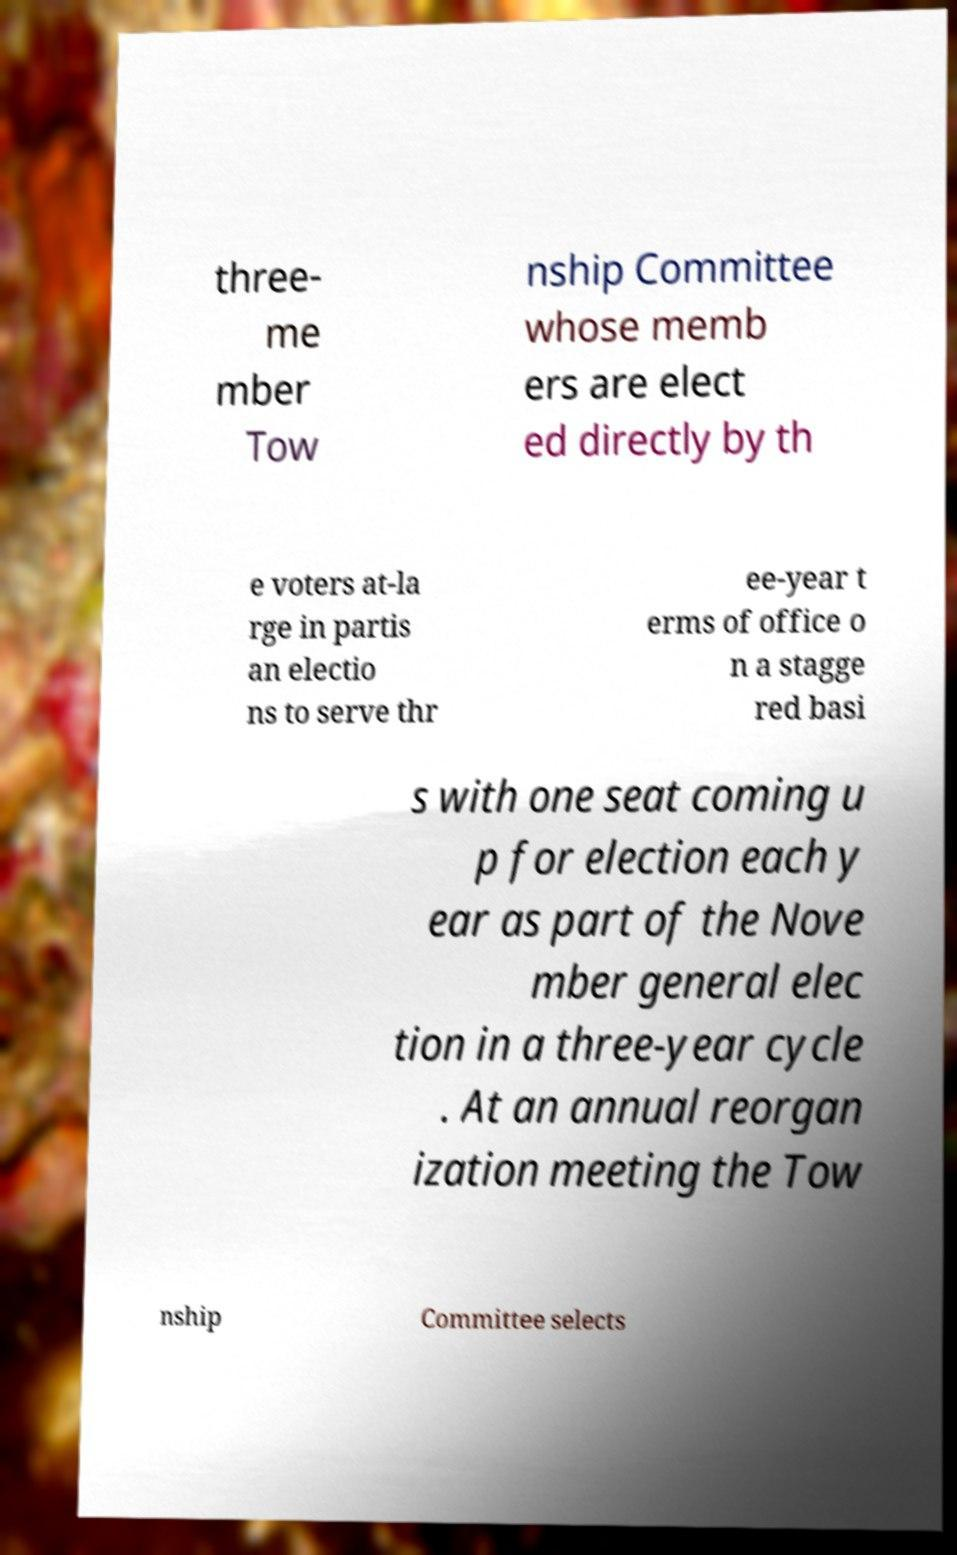Please identify and transcribe the text found in this image. three- me mber Tow nship Committee whose memb ers are elect ed directly by th e voters at-la rge in partis an electio ns to serve thr ee-year t erms of office o n a stagge red basi s with one seat coming u p for election each y ear as part of the Nove mber general elec tion in a three-year cycle . At an annual reorgan ization meeting the Tow nship Committee selects 